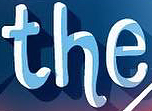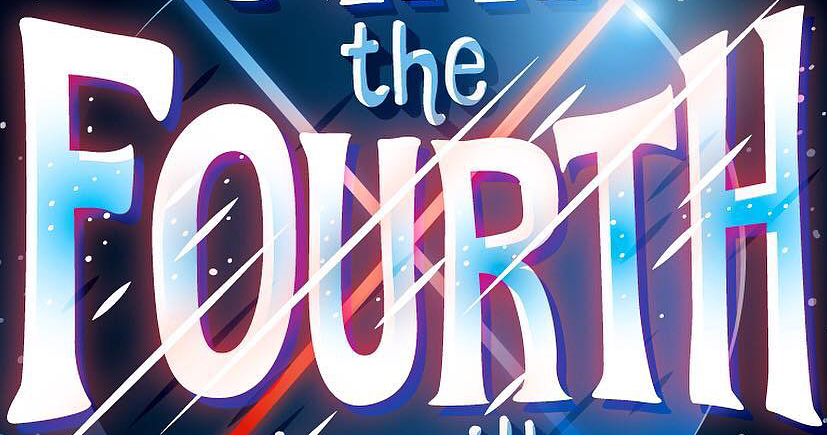What words can you see in these images in sequence, separated by a semicolon? the; FOURTH 